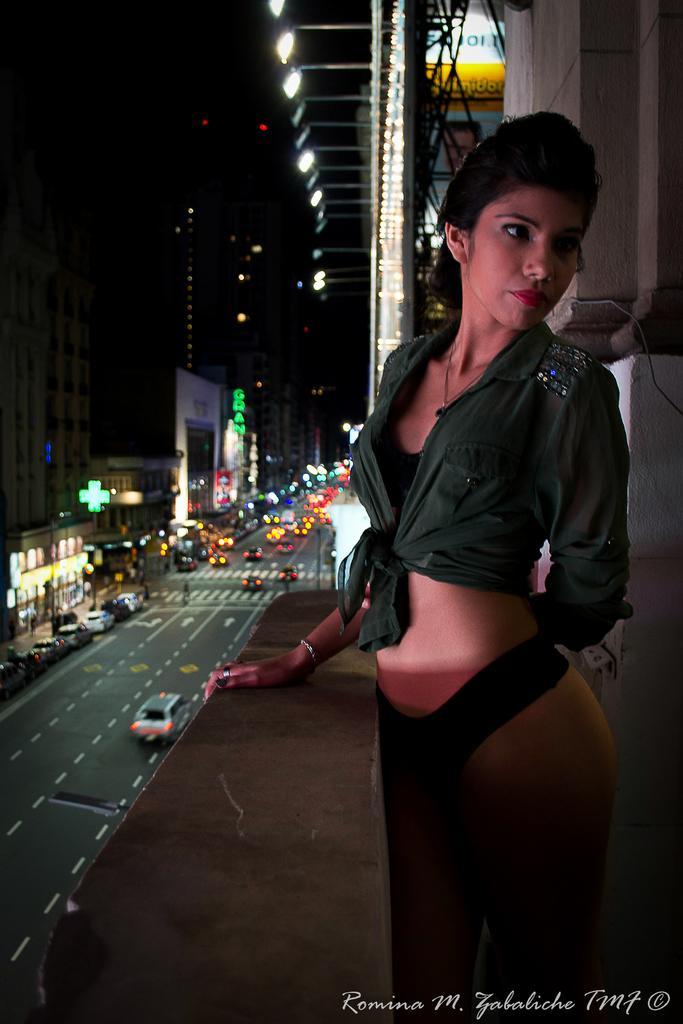In one or two sentences, can you explain what this image depicts? This image is taken in the nighttime. In this image there is a girl standing in the corridor by keeping her hand on the wall. At the bottom there is a road on which there are so many vehicles. There are buildings on either side of the road. At the top there are lights. There are few cars parked on the footpath. 